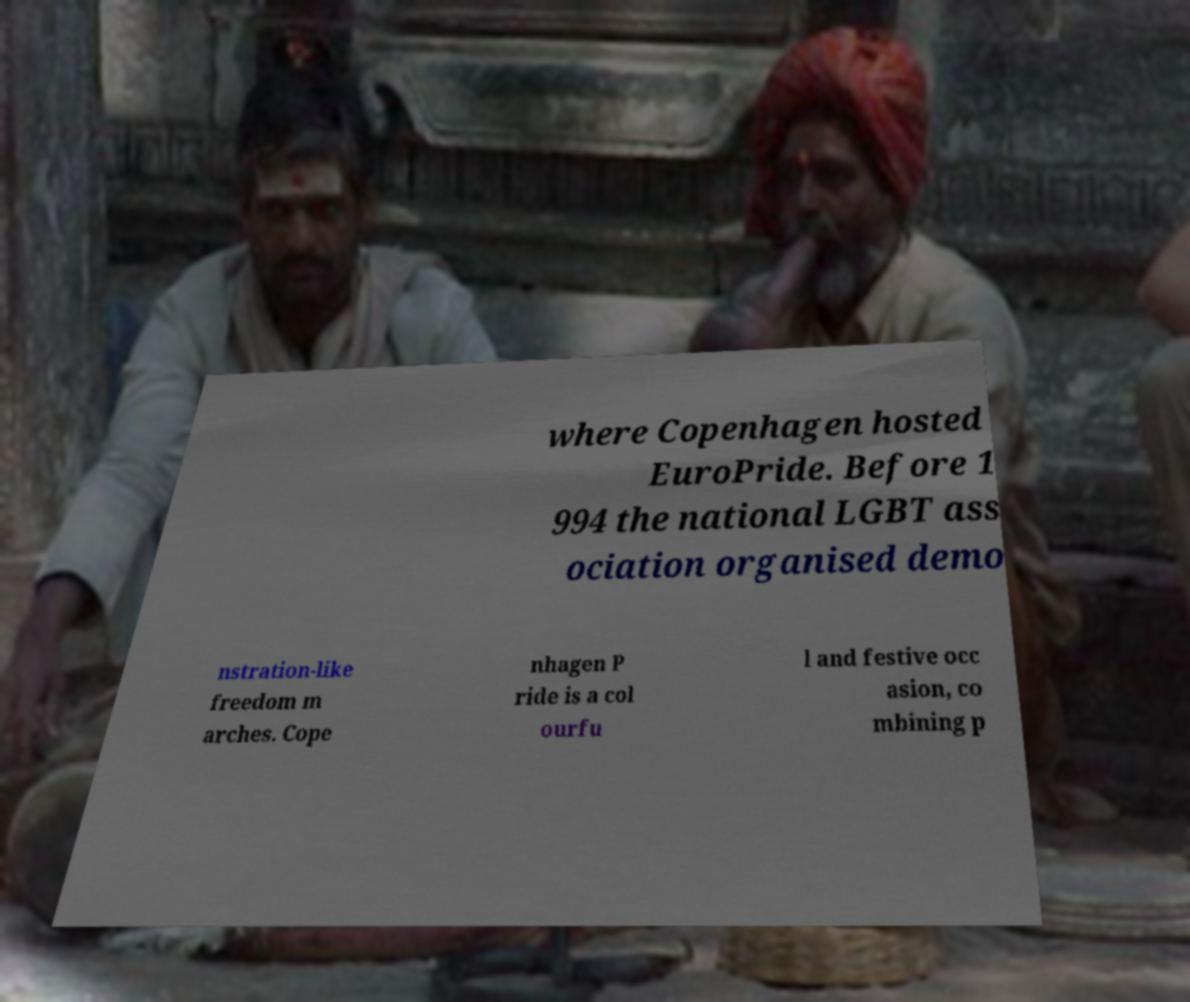There's text embedded in this image that I need extracted. Can you transcribe it verbatim? where Copenhagen hosted EuroPride. Before 1 994 the national LGBT ass ociation organised demo nstration-like freedom m arches. Cope nhagen P ride is a col ourfu l and festive occ asion, co mbining p 